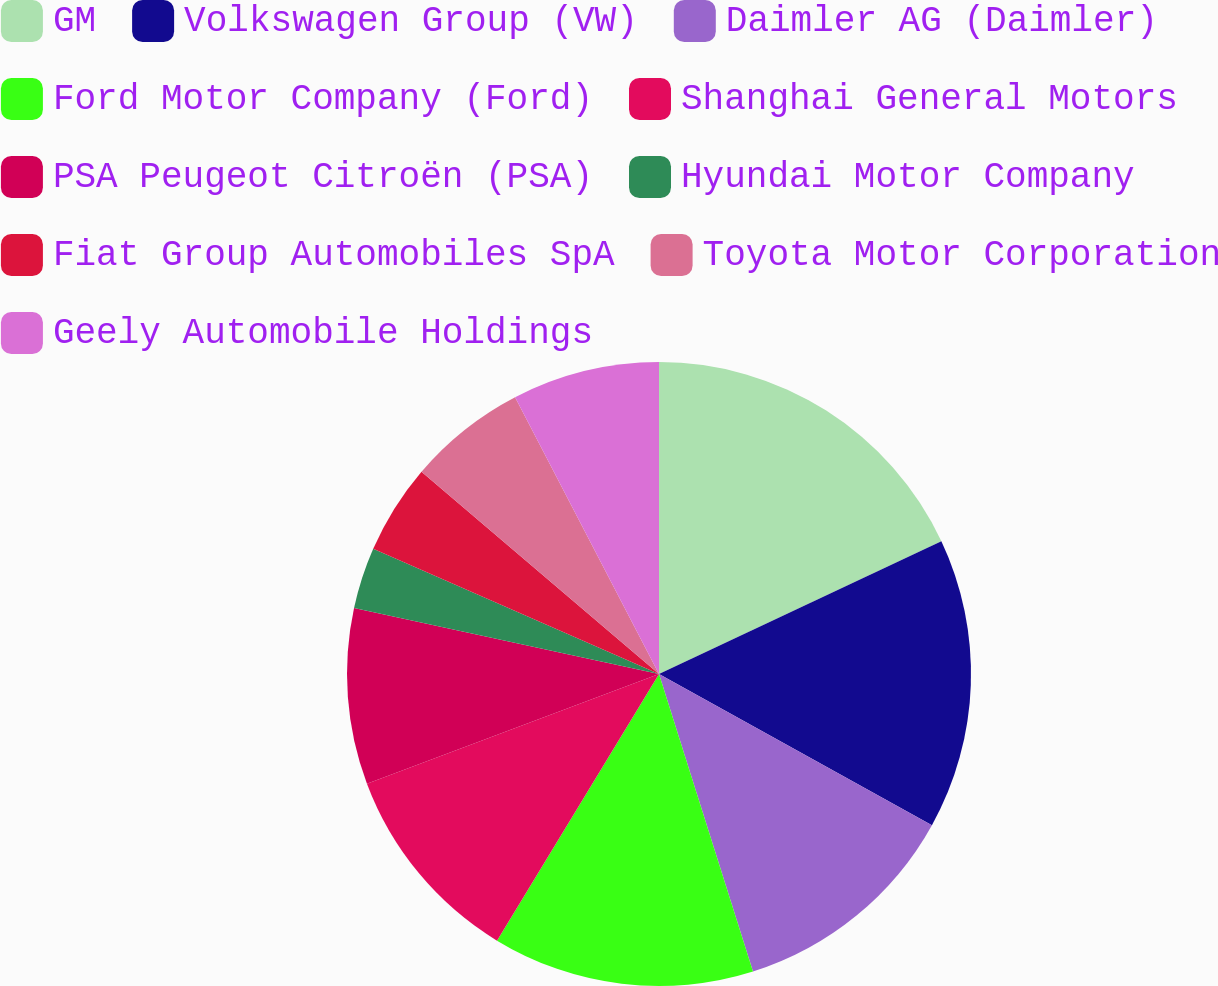Convert chart to OTSL. <chart><loc_0><loc_0><loc_500><loc_500><pie_chart><fcel>GM<fcel>Volkswagen Group (VW)<fcel>Daimler AG (Daimler)<fcel>Ford Motor Company (Ford)<fcel>Shanghai General Motors<fcel>PSA Peugeot Citroën (PSA)<fcel>Hyundai Motor Company<fcel>Fiat Group Automobiles SpA<fcel>Toyota Motor Corporation<fcel>Geely Automobile Holdings<nl><fcel>18.01%<fcel>15.04%<fcel>12.08%<fcel>13.56%<fcel>10.59%<fcel>9.11%<fcel>3.18%<fcel>4.66%<fcel>6.14%<fcel>7.63%<nl></chart> 